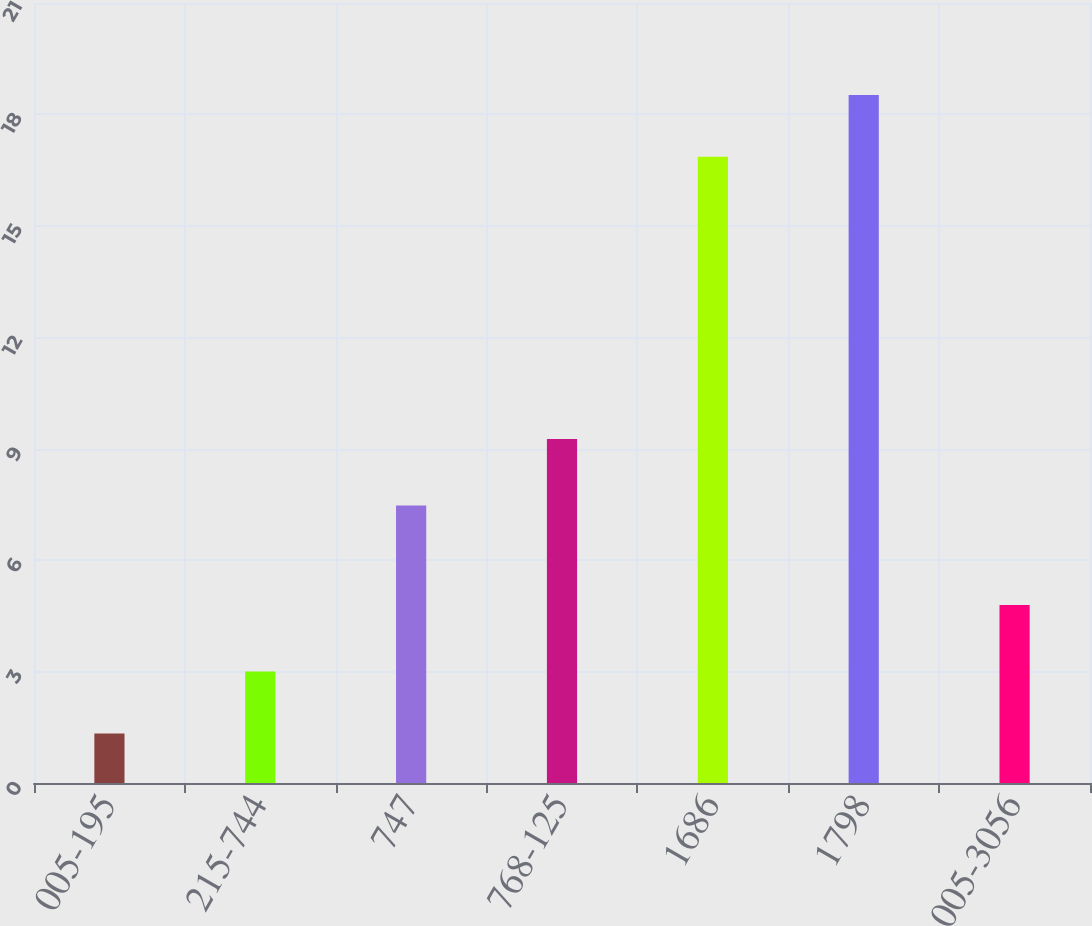Convert chart. <chart><loc_0><loc_0><loc_500><loc_500><bar_chart><fcel>005-195<fcel>215-744<fcel>747<fcel>768-125<fcel>1686<fcel>1798<fcel>005-3056<nl><fcel>1.33<fcel>3<fcel>7.47<fcel>9.26<fcel>16.86<fcel>18.52<fcel>4.79<nl></chart> 